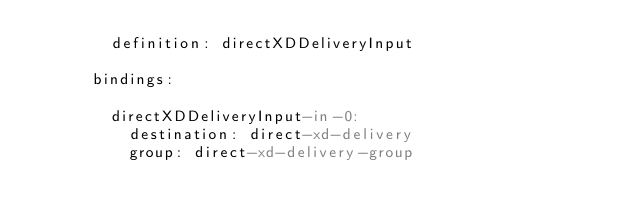Convert code to text. <code><loc_0><loc_0><loc_500><loc_500><_YAML_>        definition: directXDDeliveryInput
        
      bindings:                
       
        directXDDeliveryInput-in-0: 
          destination: direct-xd-delivery    
          group: direct-xd-delivery-group                 </code> 